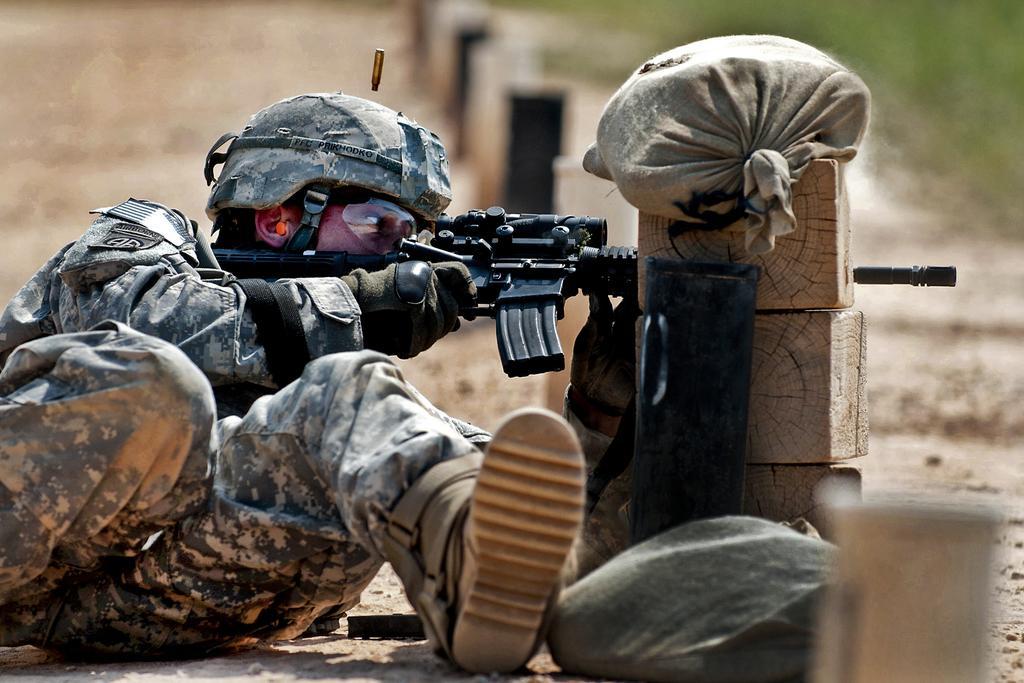How would you summarize this image in a sentence or two? In this image in the foreground there is one person who is holding a gun and he is wearing a helmet and goggles. Beside him there are some boxes and some bags, and in the background there is grass and sand and some objects. 